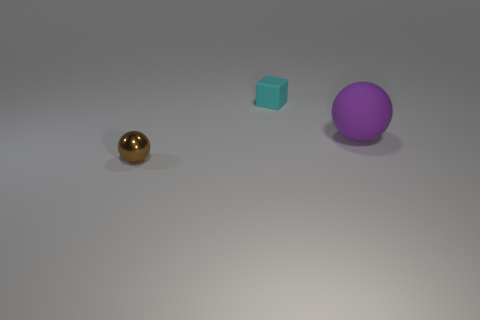Are there fewer spheres to the left of the brown sphere than balls that are behind the small matte block?
Give a very brief answer. No. What material is the brown sphere that is the same size as the cyan object?
Your answer should be compact. Metal. What shape is the brown shiny object that is the same size as the cyan thing?
Offer a very short reply. Sphere. Are there more cyan things that are right of the cyan thing than big matte balls that are to the left of the purple ball?
Provide a succinct answer. No. There is a purple thing; how many blocks are behind it?
Ensure brevity in your answer.  1. Does the small ball have the same material as the sphere right of the tiny cyan thing?
Provide a short and direct response. No. Is there anything else that has the same shape as the tiny brown metal thing?
Offer a very short reply. Yes. Does the purple ball have the same material as the tiny cyan thing?
Make the answer very short. Yes. Is there a small object to the left of the thing that is behind the large purple object?
Give a very brief answer. Yes. What number of objects are in front of the purple matte thing and to the right of the small cyan cube?
Keep it short and to the point. 0. 